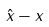Convert formula to latex. <formula><loc_0><loc_0><loc_500><loc_500>\hat { x } - x</formula> 